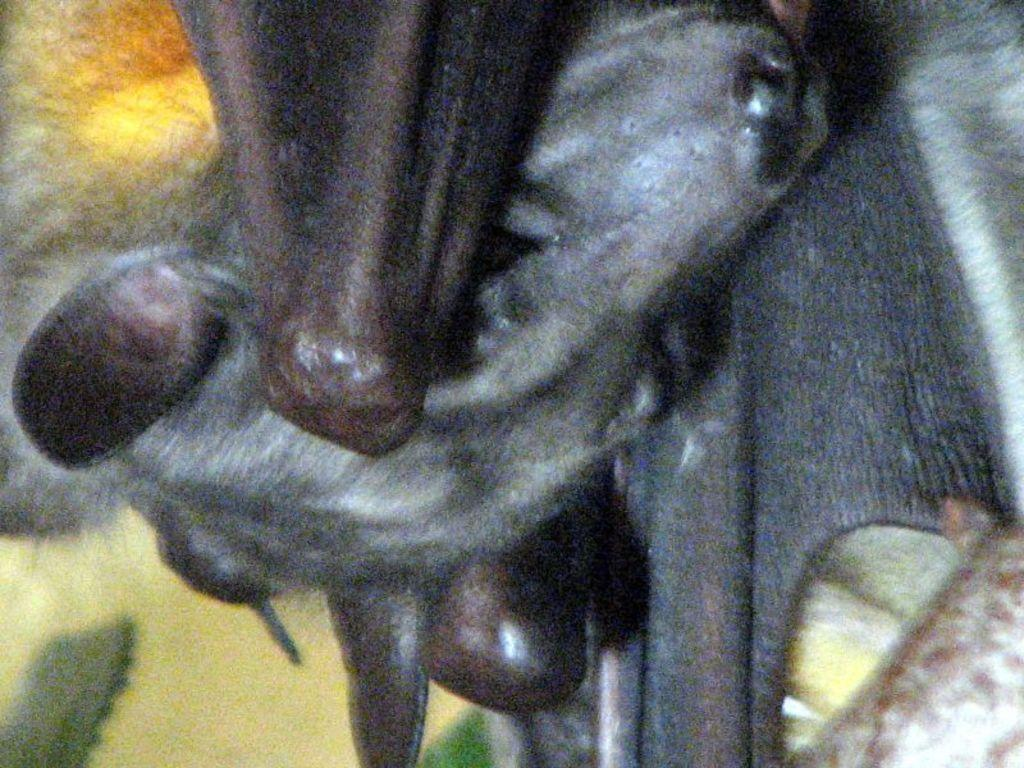What is the main subject of the image? There is an animal's face visible in the image. Can you describe the position of the animal's face in relation to other objects? The animal's face is between two objects. What type of object can be seen on the right side of the image? There is a wooden log on the right side of the image. How many cherries are on the animal's face in the image? There are no cherries present on the animal's face in the image. Is there a prison visible in the image? There is no prison visible in the image. 